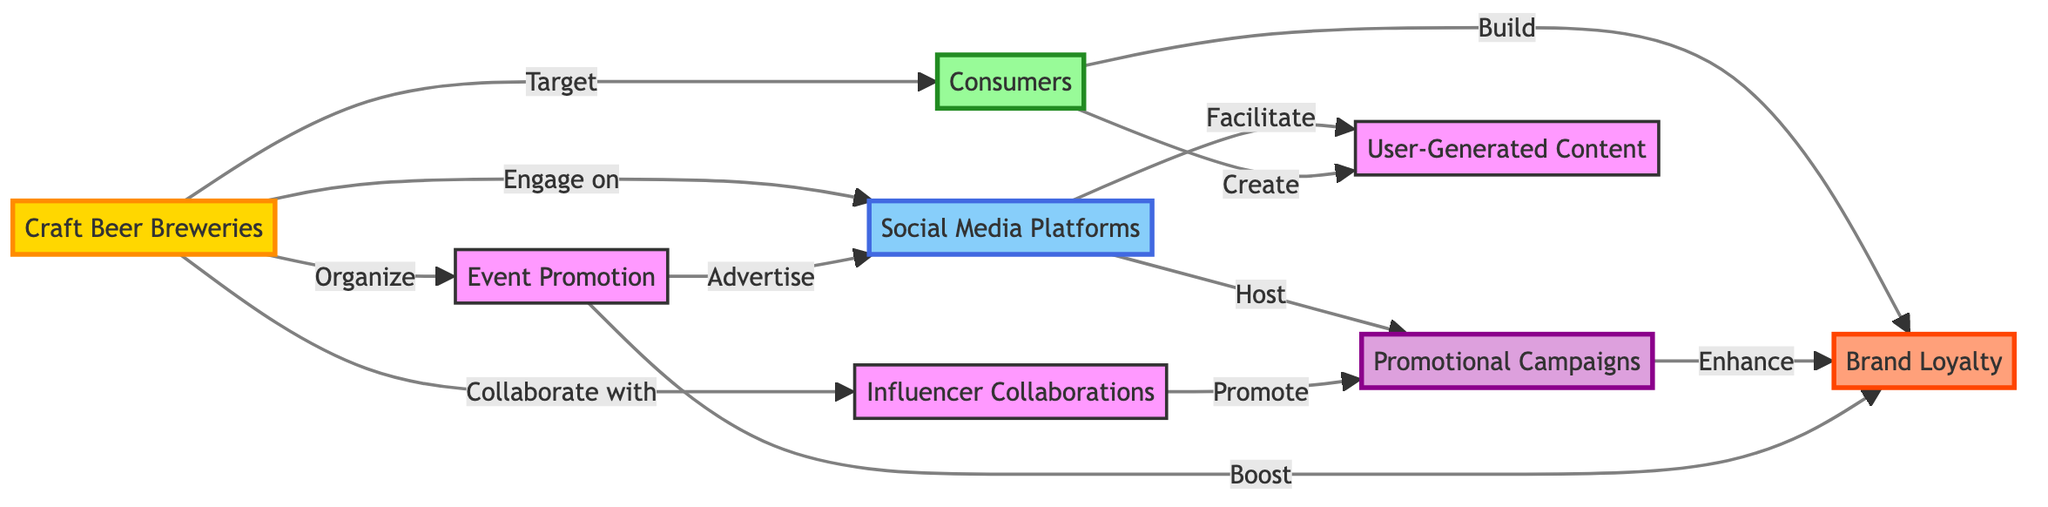What are the main entities involved in the diagram? The diagram identifies four main entities: Craft Beer Breweries, Social Media Platforms, Consumers, and Brand Loyalty. Each is represented by a specific node in the flowchart.
Answer: Craft Beer Breweries, Social Media Platforms, Consumers, Brand Loyalty How many nodes are present in the diagram? By counting each distinct element in the diagram, including actions and entities, we find a total of eight nodes represented.
Answer: 8 What type of content do consumers create on social media? According to the diagram, consumers are involved in creating User-Generated Content, emphasizing their role in contributing to the social media landscape related to craft beer.
Answer: User-Generated Content What action do craft beer breweries take to target consumers? The diagram shows that craft beer breweries specifically aim to "Target" consumers as a way of reaching their audience for marketing purposes.
Answer: Target How does event promotion affect brand loyalty? The diagram indicates that organizing events helps "Boost" brand loyalty, showing an important contribution of events to enhancing consumer attachment to the brand.
Answer: Boost What two actions are linked to social media platforms? The diagram illustrates that social media platforms facilitate User-Generated Content and host Promotional Campaigns as key functionalities for craft beer marketing.
Answer: Facilitate, Host What is the relationship between influencer collaborations and promotional campaigns? The flowchart depicts that influencer collaborations "Promote" promotional campaigns, indicating a direct connection between these marketing strategies.
Answer: Promote In what ways do craft beer breweries engage with social media platforms? The diagram states that craft beer breweries "Engage on" social media platforms, highlighting the foundational role of this engagement in their marketing strategy.
Answer: Engage on What effect do promotional campaigns have on brand loyalty? According to the diagram, promotional campaigns are said to "Enhance" brand loyalty, suggesting their positive impact on customer attachment to the brewery.
Answer: Enhance 